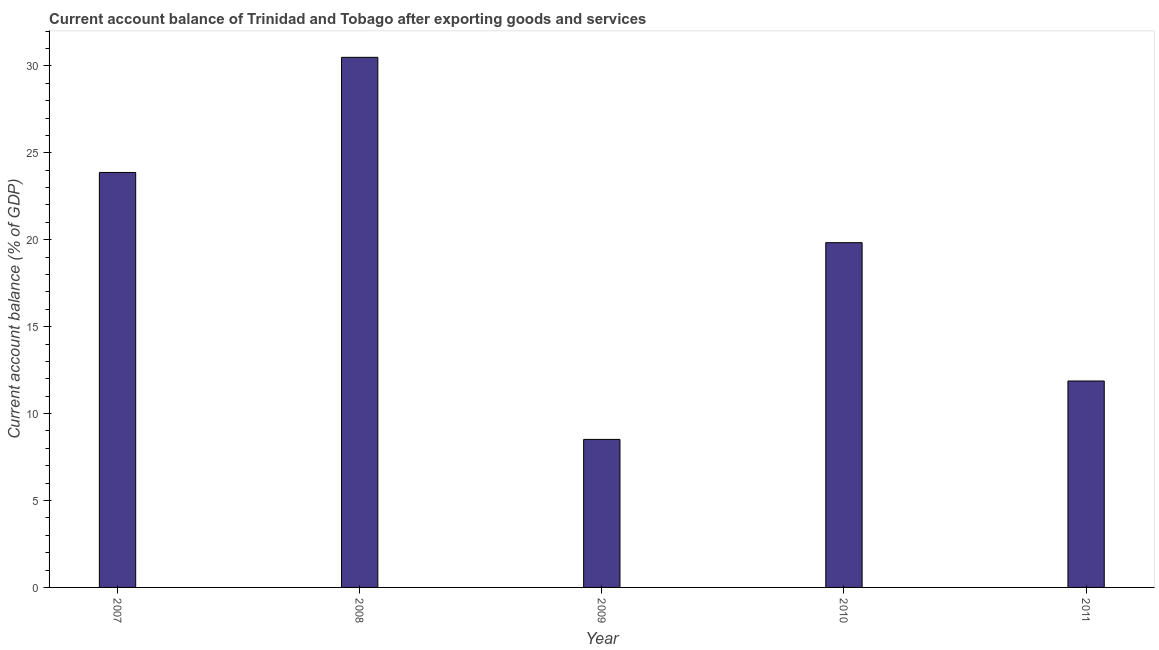Does the graph contain any zero values?
Offer a very short reply. No. Does the graph contain grids?
Keep it short and to the point. No. What is the title of the graph?
Give a very brief answer. Current account balance of Trinidad and Tobago after exporting goods and services. What is the label or title of the X-axis?
Offer a very short reply. Year. What is the label or title of the Y-axis?
Your answer should be compact. Current account balance (% of GDP). What is the current account balance in 2008?
Offer a terse response. 30.5. Across all years, what is the maximum current account balance?
Ensure brevity in your answer.  30.5. Across all years, what is the minimum current account balance?
Provide a succinct answer. 8.52. In which year was the current account balance maximum?
Keep it short and to the point. 2008. In which year was the current account balance minimum?
Your response must be concise. 2009. What is the sum of the current account balance?
Your answer should be compact. 94.59. What is the difference between the current account balance in 2007 and 2010?
Offer a very short reply. 4.04. What is the average current account balance per year?
Make the answer very short. 18.92. What is the median current account balance?
Your response must be concise. 19.83. What is the ratio of the current account balance in 2007 to that in 2010?
Provide a short and direct response. 1.2. Is the current account balance in 2008 less than that in 2009?
Give a very brief answer. No. Is the difference between the current account balance in 2008 and 2009 greater than the difference between any two years?
Keep it short and to the point. Yes. What is the difference between the highest and the second highest current account balance?
Make the answer very short. 6.62. Is the sum of the current account balance in 2010 and 2011 greater than the maximum current account balance across all years?
Ensure brevity in your answer.  Yes. What is the difference between the highest and the lowest current account balance?
Your answer should be compact. 21.98. Are all the bars in the graph horizontal?
Your answer should be very brief. No. What is the Current account balance (% of GDP) of 2007?
Your answer should be very brief. 23.87. What is the Current account balance (% of GDP) of 2008?
Ensure brevity in your answer.  30.5. What is the Current account balance (% of GDP) in 2009?
Keep it short and to the point. 8.52. What is the Current account balance (% of GDP) in 2010?
Offer a very short reply. 19.83. What is the Current account balance (% of GDP) in 2011?
Your answer should be very brief. 11.87. What is the difference between the Current account balance (% of GDP) in 2007 and 2008?
Offer a terse response. -6.62. What is the difference between the Current account balance (% of GDP) in 2007 and 2009?
Offer a terse response. 15.36. What is the difference between the Current account balance (% of GDP) in 2007 and 2010?
Offer a very short reply. 4.04. What is the difference between the Current account balance (% of GDP) in 2007 and 2011?
Ensure brevity in your answer.  12. What is the difference between the Current account balance (% of GDP) in 2008 and 2009?
Your response must be concise. 21.98. What is the difference between the Current account balance (% of GDP) in 2008 and 2010?
Keep it short and to the point. 10.66. What is the difference between the Current account balance (% of GDP) in 2008 and 2011?
Make the answer very short. 18.62. What is the difference between the Current account balance (% of GDP) in 2009 and 2010?
Provide a short and direct response. -11.32. What is the difference between the Current account balance (% of GDP) in 2009 and 2011?
Your response must be concise. -3.36. What is the difference between the Current account balance (% of GDP) in 2010 and 2011?
Your response must be concise. 7.96. What is the ratio of the Current account balance (% of GDP) in 2007 to that in 2008?
Offer a terse response. 0.78. What is the ratio of the Current account balance (% of GDP) in 2007 to that in 2009?
Your answer should be very brief. 2.8. What is the ratio of the Current account balance (% of GDP) in 2007 to that in 2010?
Provide a short and direct response. 1.2. What is the ratio of the Current account balance (% of GDP) in 2007 to that in 2011?
Give a very brief answer. 2.01. What is the ratio of the Current account balance (% of GDP) in 2008 to that in 2009?
Your answer should be compact. 3.58. What is the ratio of the Current account balance (% of GDP) in 2008 to that in 2010?
Give a very brief answer. 1.54. What is the ratio of the Current account balance (% of GDP) in 2008 to that in 2011?
Your answer should be compact. 2.57. What is the ratio of the Current account balance (% of GDP) in 2009 to that in 2010?
Offer a very short reply. 0.43. What is the ratio of the Current account balance (% of GDP) in 2009 to that in 2011?
Keep it short and to the point. 0.72. What is the ratio of the Current account balance (% of GDP) in 2010 to that in 2011?
Your answer should be very brief. 1.67. 